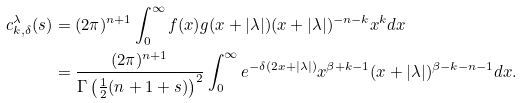Convert formula to latex. <formula><loc_0><loc_0><loc_500><loc_500>c _ { k , \delta } ^ { \lambda } ( s ) & = ( 2 \pi ) ^ { n + 1 } \int _ { 0 } ^ { \infty } f ( x ) g ( x + | \lambda | ) ( x + | \lambda | ) ^ { - n - k } x ^ { k } d x \\ & = \frac { ( 2 \pi ) ^ { n + 1 } } { \Gamma \left ( \frac { 1 } { 2 } ( n + 1 + s ) \right ) ^ { 2 } } \int _ { 0 } ^ { \infty } e ^ { - \delta ( 2 x + | \lambda | ) } x ^ { \beta + k - 1 } ( x + | \lambda | ) ^ { \beta - k - n - 1 } d x .</formula> 